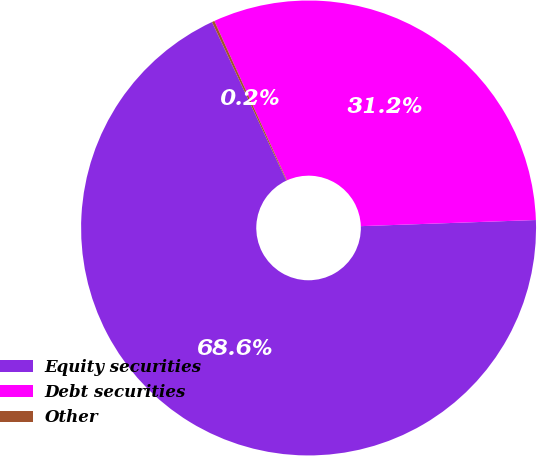<chart> <loc_0><loc_0><loc_500><loc_500><pie_chart><fcel>Equity securities<fcel>Debt securities<fcel>Other<nl><fcel>68.57%<fcel>31.24%<fcel>0.18%<nl></chart> 